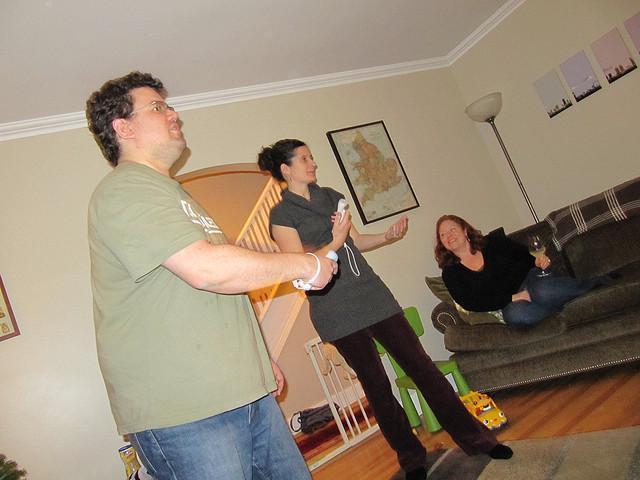What are the majority of the people doing?
Indicate the correct response and explain using: 'Answer: answer
Rationale: rationale.'
Options: Standing, eating, sitting, sleeping. Answer: standing.
Rationale: The majority of people are standing because they are playing a video game that needs them to be standing 